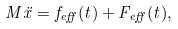<formula> <loc_0><loc_0><loc_500><loc_500>M \ddot { x } = f _ { e f f } ( t ) + F _ { e f f } ( t ) ,</formula> 